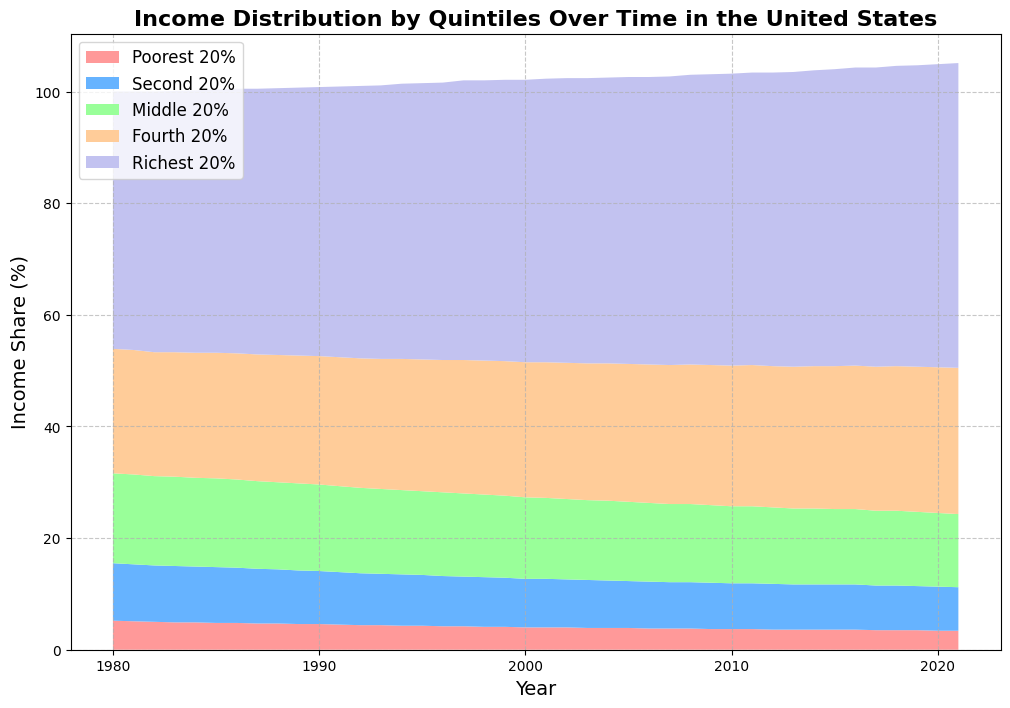What was the income share of the richest 20% in 1980? The figure shows the income distribution over time, and you can refer to the stacked area representing the richest 20% in the year 1980. The value at that point is 46.1%.
Answer: 46.1% Between 1980 and 2021, which quintile saw the most significant increase in income share? Visually inspecting the stacked areas, the area representing the richest 20% increased the most from 1980 to 2021.
Answer: Richest 20% In which year did the poorest 20% hold their lowest share of income? By examining the area at the bottom of the chart—representing the poorest 20%—it is smallest around the year 2020. The exact figure for 2020 is 3.4%.
Answer: 2020 How did the income share change for the middle 20% from 1980 to 2021? The middle 20% area can be tracked across the years. In 1980, it is 16.1%, and by 2021, it drops to 13.1%. Thus, there is a decrease of 3%.
Answer: Decreased by 3% Which quintile consistently had the smallest income share over the years, and what visual clue helped you determine that? The poorest 20% consistently had the smallest income share, as seen by the smallest and bottom-most area on the chart throughout the timeline.
Answer: Poorest 20% Compare the income shares of the second 20% and the fourth 20% in 2000. Which quintile had a higher share, and by how much? In 2000, the second 20% had a share of 8.7%, and the fourth 20% had 24.2%. The fourth 20% had a higher share by 15.5%.
Answer: Fourth 20% by 15.5% Describe the trend in the income share of the richest 20% from 1980 to 2021. The area graph shows a gradual increase in the income share of the richest 20% from 46.1% in 1980 to 54.6% in 2021, indicating growing income inequality.
Answer: Gradual increase What can you infer about income inequality from the trend of the poorest 20% and the richest 20%? The poorest 20% saw a decline in their income share from 5.2% in 1980 to 3.4% in 2021, while the richest 20% saw an increase from 46.1% to 54.6%. This suggests that income inequality has widened over time.
Answer: Increased income inequality Which quintile showed the least change in its income share over the period, and how can you tell? The fourth 20% shows the least amount of change as the area it occupies remains more consistent compared to others, increasing slightly from 22.3% in 1980 to 26.2% in 2021.
Answer: Fourth 20% 